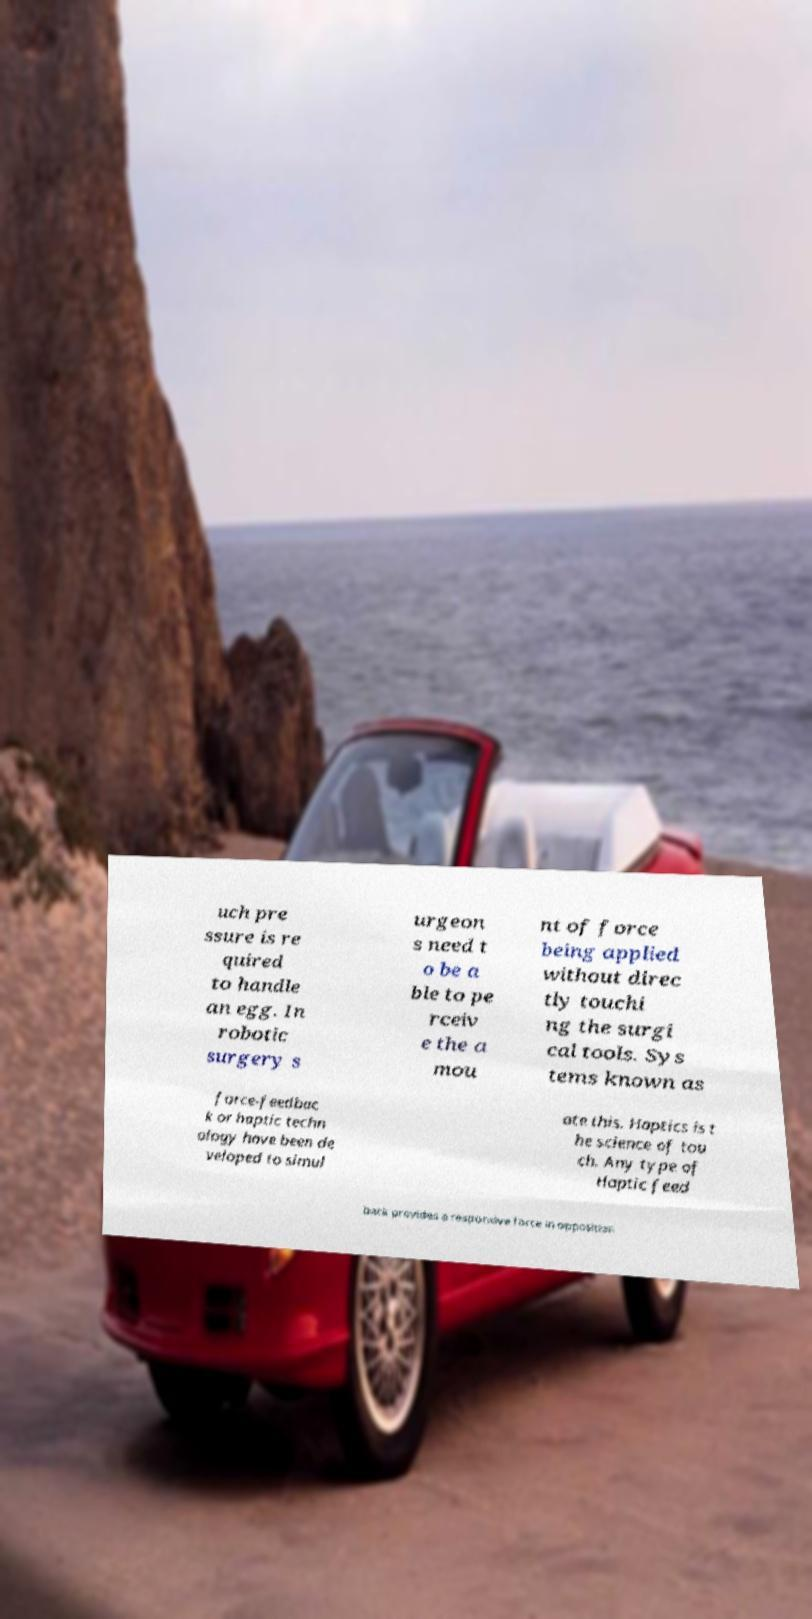Can you accurately transcribe the text from the provided image for me? uch pre ssure is re quired to handle an egg. In robotic surgery s urgeon s need t o be a ble to pe rceiv e the a mou nt of force being applied without direc tly touchi ng the surgi cal tools. Sys tems known as force-feedbac k or haptic techn ology have been de veloped to simul ate this. Haptics is t he science of tou ch. Any type of Haptic feed back provides a responsive force in opposition 